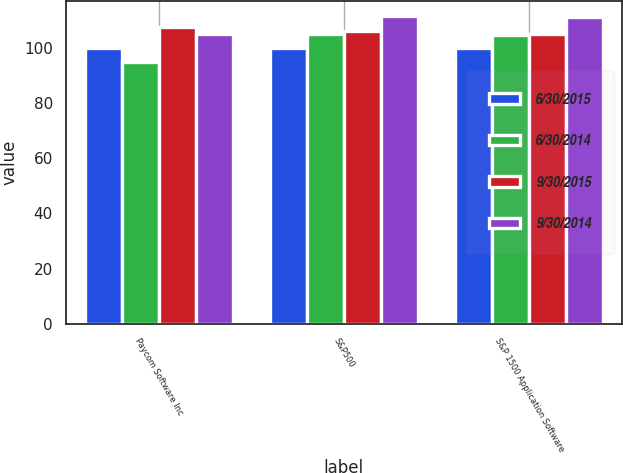<chart> <loc_0><loc_0><loc_500><loc_500><stacked_bar_chart><ecel><fcel>Paycom Software Inc<fcel>S&P500<fcel>S&P 1500 Application Software<nl><fcel>6/30/2015<fcel>100<fcel>100<fcel>100<nl><fcel>6/30/2014<fcel>95.05<fcel>105.23<fcel>104.92<nl><fcel>9/30/2015<fcel>107.88<fcel>106.42<fcel>105.17<nl><fcel>9/30/2014<fcel>105.17<fcel>111.67<fcel>111.27<nl></chart> 